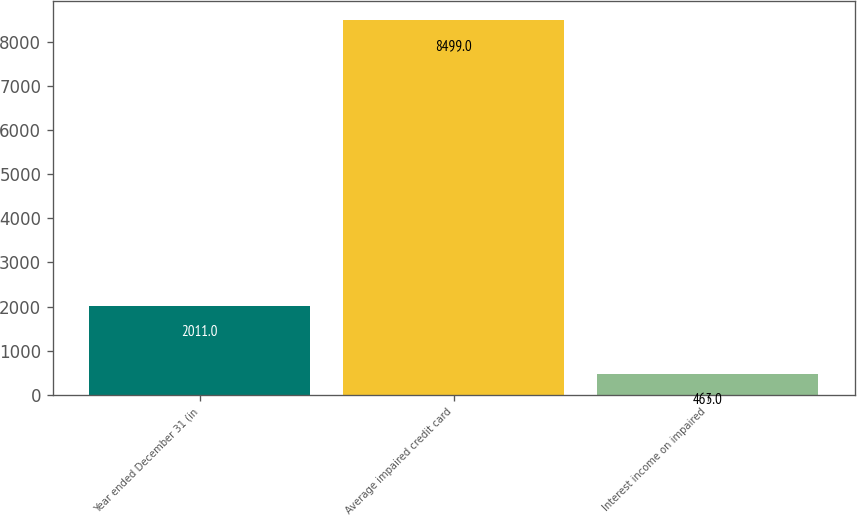Convert chart. <chart><loc_0><loc_0><loc_500><loc_500><bar_chart><fcel>Year ended December 31 (in<fcel>Average impaired credit card<fcel>Interest income on impaired<nl><fcel>2011<fcel>8499<fcel>463<nl></chart> 